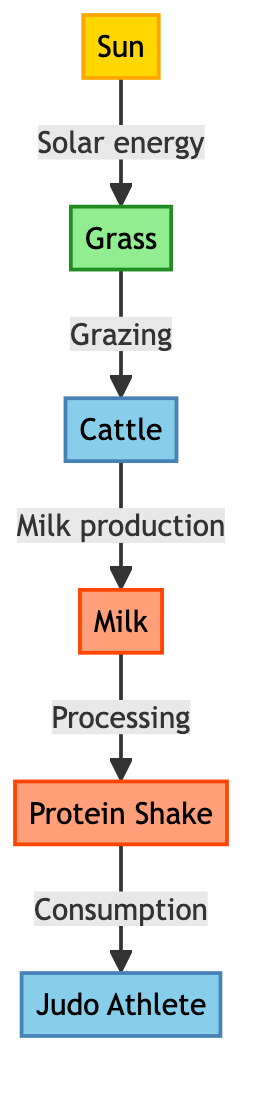What is the source of energy in this food chain? The diagram shows the sun as the first element, labeled as "Sun," which is categorized as a source. It directly transfers solar energy to the grass.
Answer: Sun How many producers are in the diagram? The diagram includes one producer, labeled as "Grass," which is indicated by its position in the flow where it receives energy from the sun.
Answer: One What type of product is obtained from cattle? Cattle are shown to produce "Milk" after grazing on grass, which is specified as a product in the flow of the diagram.
Answer: Milk Who consumes the protein shake? The diagram indicates that the "Judo Athlete" is the final consumer who consumes the protein shake, as shown by the last connection in the flow.
Answer: Judo Athlete What flows from cattle to milk? The diagram describes the flow from cattle to milk as "Milk production," indicating the process that occurs after cattle graze.
Answer: Milk production Which node represents the final consumer in this food chain? The "Judo Athlete" is at the end of the flow, indicating they are the final consumer of energy sources in this food chain structure.
Answer: Judo Athlete What is processed after milk in the diagram? According to the flow in the diagram, "Protein Shake" is produced through the processing of milk, indicating the sequence of events.
Answer: Protein Shake What type of relationship exists between grass and cattle? The relationship described in the flow from grass to cattle is marked as "Grazing," illustrating how cattle feed on grass.
Answer: Grazing 